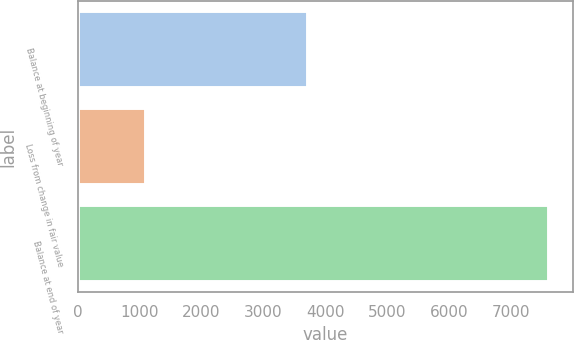Convert chart. <chart><loc_0><loc_0><loc_500><loc_500><bar_chart><fcel>Balance at beginning of year<fcel>Loss from change in fair value<fcel>Balance at end of year<nl><fcel>3724<fcel>1106<fcel>7618<nl></chart> 